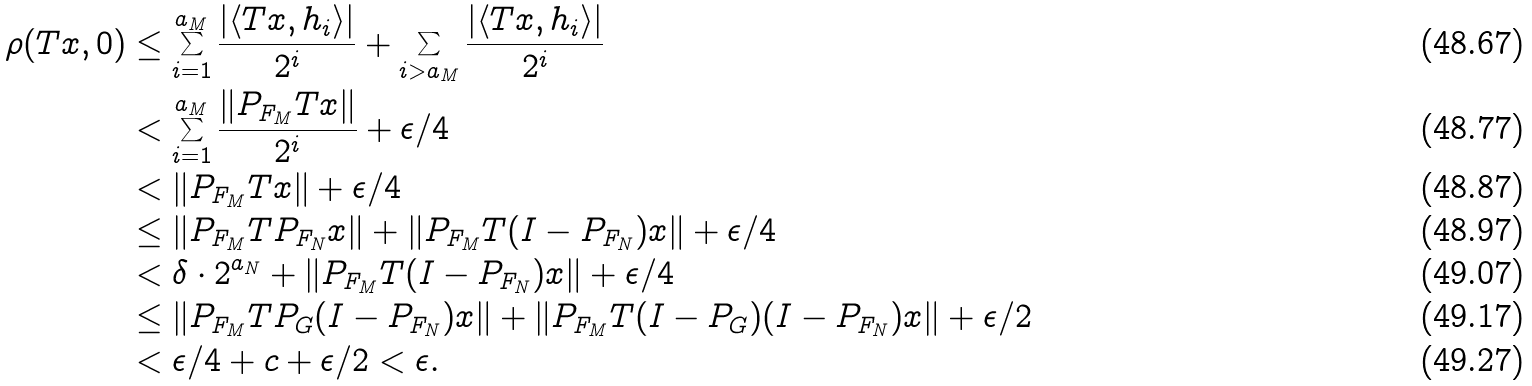Convert formula to latex. <formula><loc_0><loc_0><loc_500><loc_500>\rho ( T x , 0 ) & \leq \sum _ { i = 1 } ^ { a _ { M } } \frac { | \langle T x , h _ { i } \rangle | } { 2 ^ { i } } + \sum _ { i > a _ { M } } \frac { | \langle T x , h _ { i } \rangle | } { 2 ^ { i } } \\ & < \sum _ { i = 1 } ^ { a _ { M } } \frac { \| P _ { F _ { M } } T x \| } { 2 ^ { i } } + \epsilon / 4 \\ & < \| P _ { F _ { M } } T x \| + \epsilon / 4 \\ & \leq \| P _ { F _ { M } } T P _ { F _ { N } } x \| + \| P _ { F _ { M } } T ( I - P _ { F _ { N } } ) x \| + \epsilon / 4 \\ & < \delta \cdot 2 ^ { a _ { N } } + \| P _ { F _ { M } } T ( I - P _ { F _ { N } } ) x \| + \epsilon / 4 \\ & \leq \| P _ { F _ { M } } T P _ { G } ( I - P _ { F _ { N } } ) x \| + \| P _ { F _ { M } } T ( I - P _ { G } ) ( I - P _ { F _ { N } } ) x \| + \epsilon / 2 \\ & < \epsilon / 4 + c + \epsilon / 2 < \epsilon .</formula> 